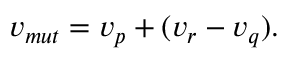Convert formula to latex. <formula><loc_0><loc_0><loc_500><loc_500>{ } v _ { m u t } = v _ { p } + ( v _ { r } - v _ { q } ) .</formula> 